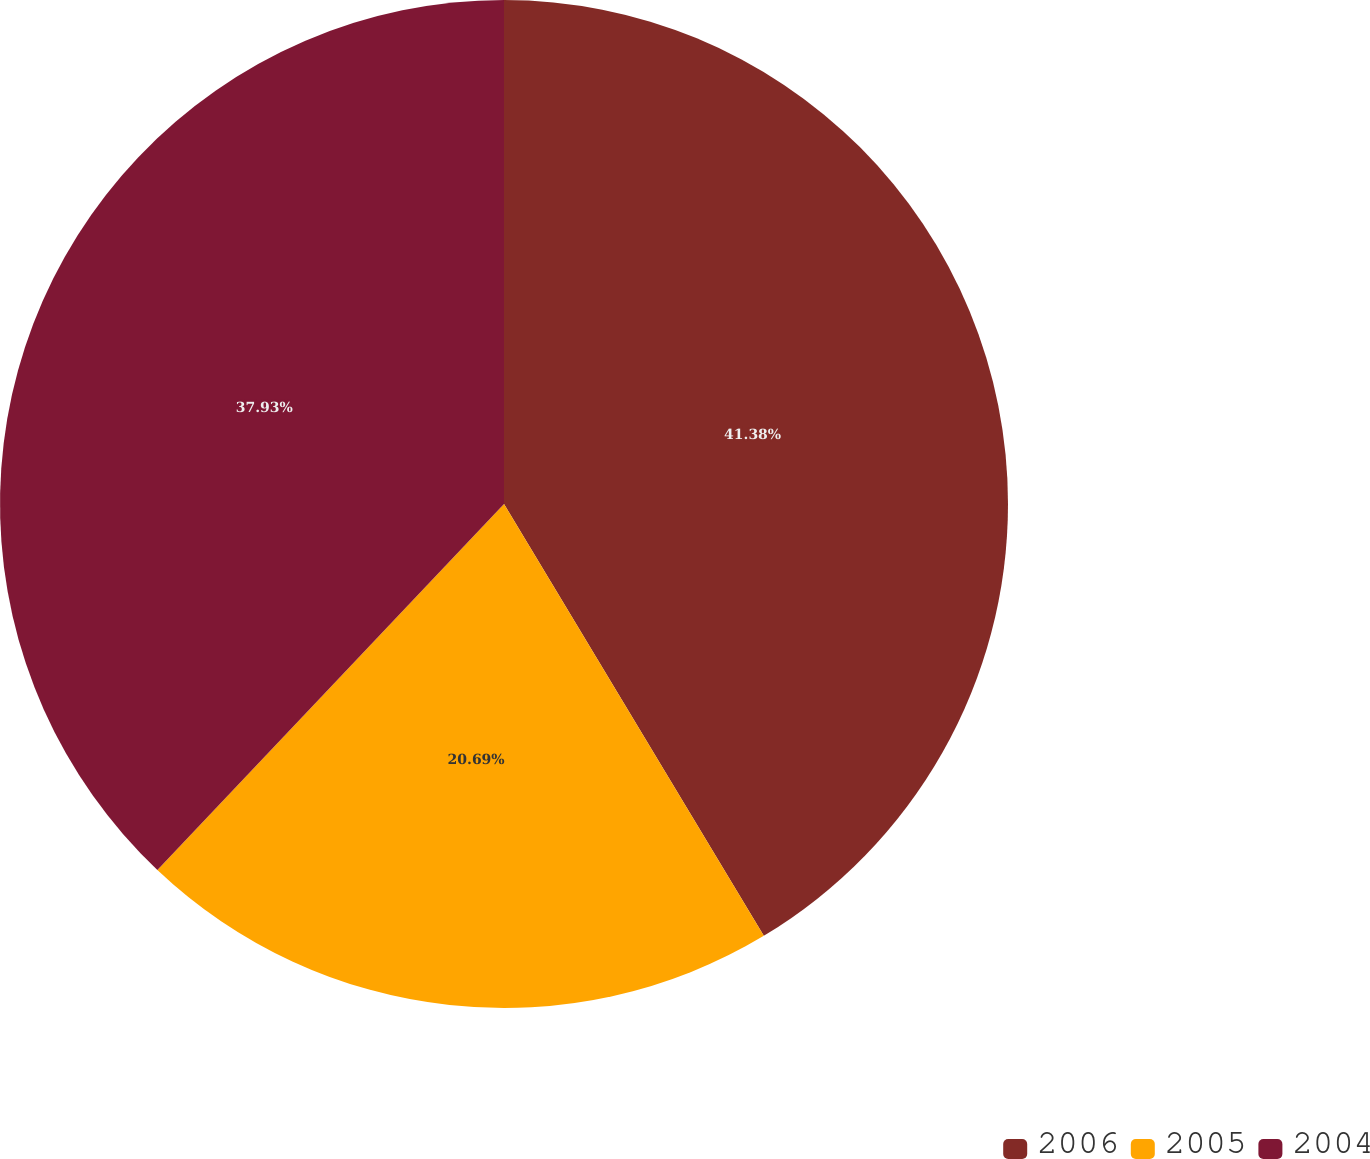Convert chart. <chart><loc_0><loc_0><loc_500><loc_500><pie_chart><fcel>2006<fcel>2005<fcel>2004<nl><fcel>41.38%<fcel>20.69%<fcel>37.93%<nl></chart> 